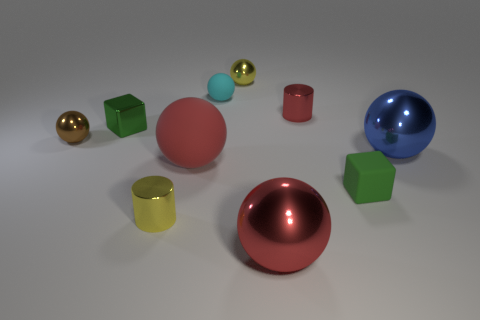Subtract all purple blocks. How many red balls are left? 2 Subtract all cyan spheres. How many spheres are left? 5 Subtract 2 spheres. How many spheres are left? 4 Subtract all red spheres. How many spheres are left? 4 Subtract all gray spheres. Subtract all red blocks. How many spheres are left? 6 Subtract all cubes. How many objects are left? 8 Subtract 1 yellow cylinders. How many objects are left? 9 Subtract all brown things. Subtract all purple metal cubes. How many objects are left? 9 Add 9 small yellow metal balls. How many small yellow metal balls are left? 10 Add 7 tiny gray shiny spheres. How many tiny gray shiny spheres exist? 7 